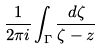<formula> <loc_0><loc_0><loc_500><loc_500>\frac { 1 } { 2 \pi i } \int _ { \Gamma } \frac { d \zeta } { \zeta - z }</formula> 